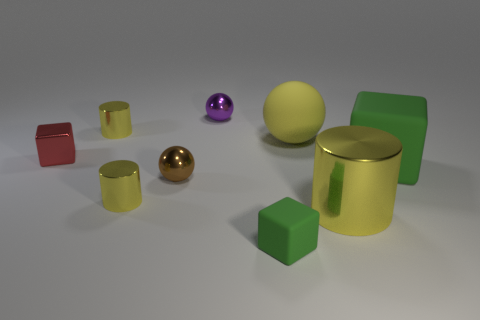Subtract 1 cylinders. How many cylinders are left? 2 Add 1 small matte things. How many objects exist? 10 Subtract all cylinders. How many objects are left? 6 Add 1 blue cylinders. How many blue cylinders exist? 1 Subtract 0 red spheres. How many objects are left? 9 Subtract all big matte things. Subtract all tiny shiny cylinders. How many objects are left? 5 Add 9 large matte cubes. How many large matte cubes are left? 10 